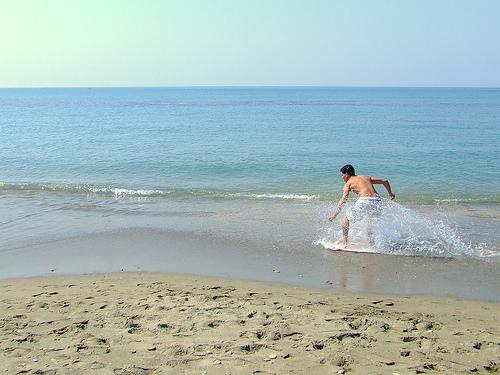Question: what is the man doing?
Choices:
A. Skiing.
B. Surfing.
C. Swimming.
D. Running.
Answer with the letter. Answer: B Question: where was this picture taken?
Choices:
A. A ship.
B. A pool.
C. A tent.
D. A beach.
Answer with the letter. Answer: D Question: what color is the man's shorts?
Choices:
A. Green.
B. Red.
C. Black.
D. Blue.
Answer with the letter. Answer: D 